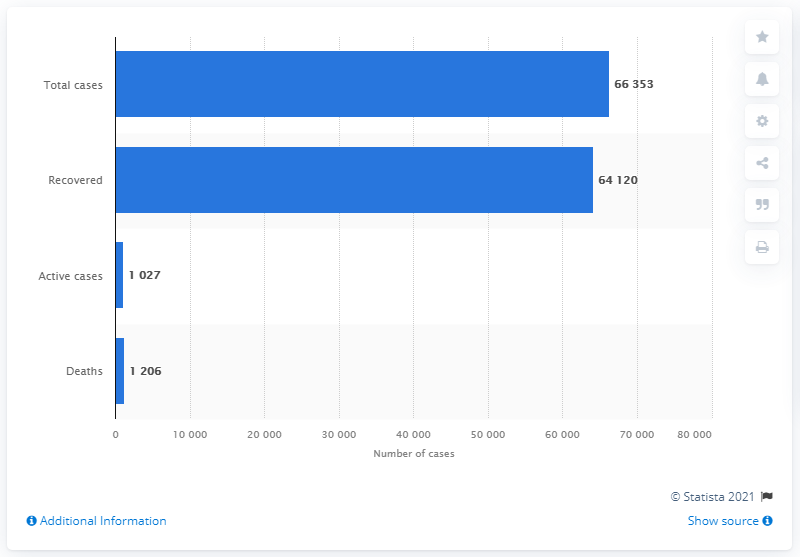Indicate a few pertinent items in this graphic. As of June 20, 2021, there had been a total of 66,353 cases of COVID-19 reported worldwide. As of today, 64,120 patients have recovered from COVID-19. 